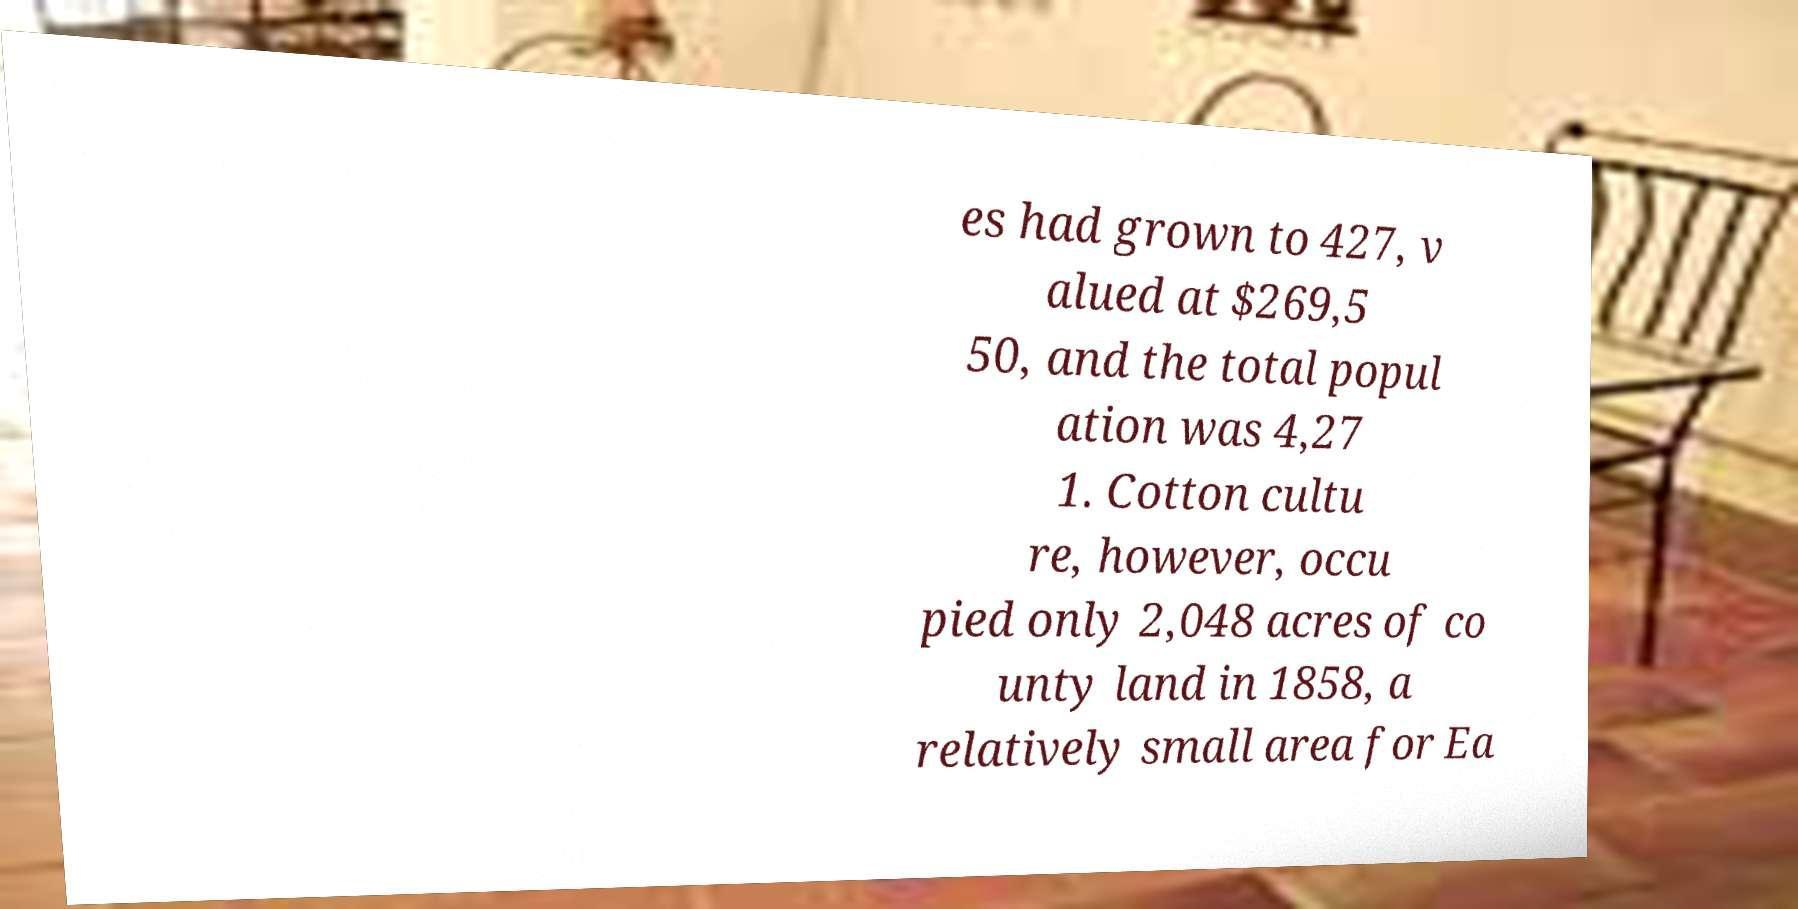Could you assist in decoding the text presented in this image and type it out clearly? es had grown to 427, v alued at $269,5 50, and the total popul ation was 4,27 1. Cotton cultu re, however, occu pied only 2,048 acres of co unty land in 1858, a relatively small area for Ea 